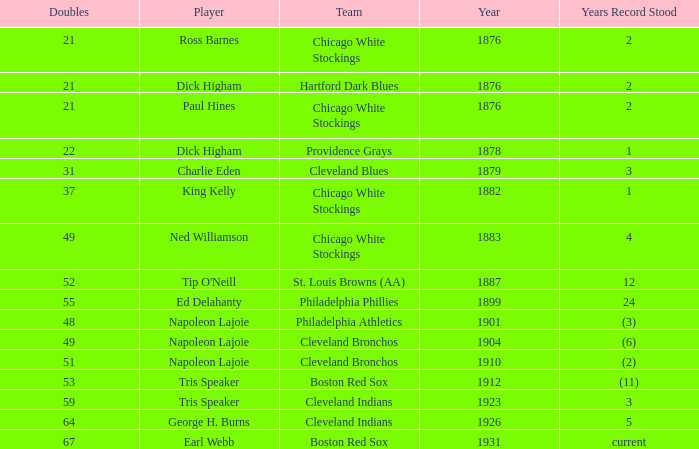In which year was the record set for 49 doubles by napoleon lajoie, a player for the cleveland bronchos? (6). 